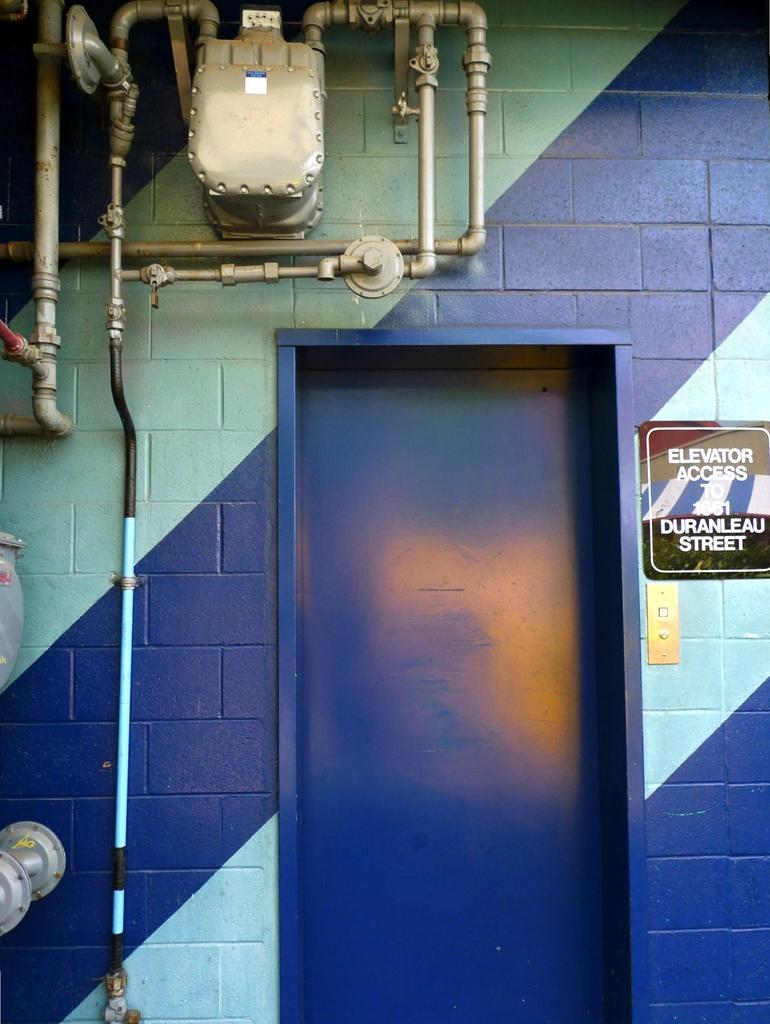What is a prominent feature of the image? There is a wall in the image. What can be found on the wall? There is a door in the wall and a board on the wall. What is written or displayed on the board? There is text on the board. What else can be seen in the image? There are pipes in the image. How many clocks are visible on the wall in the image? There are no clocks visible on the wall in the image. 